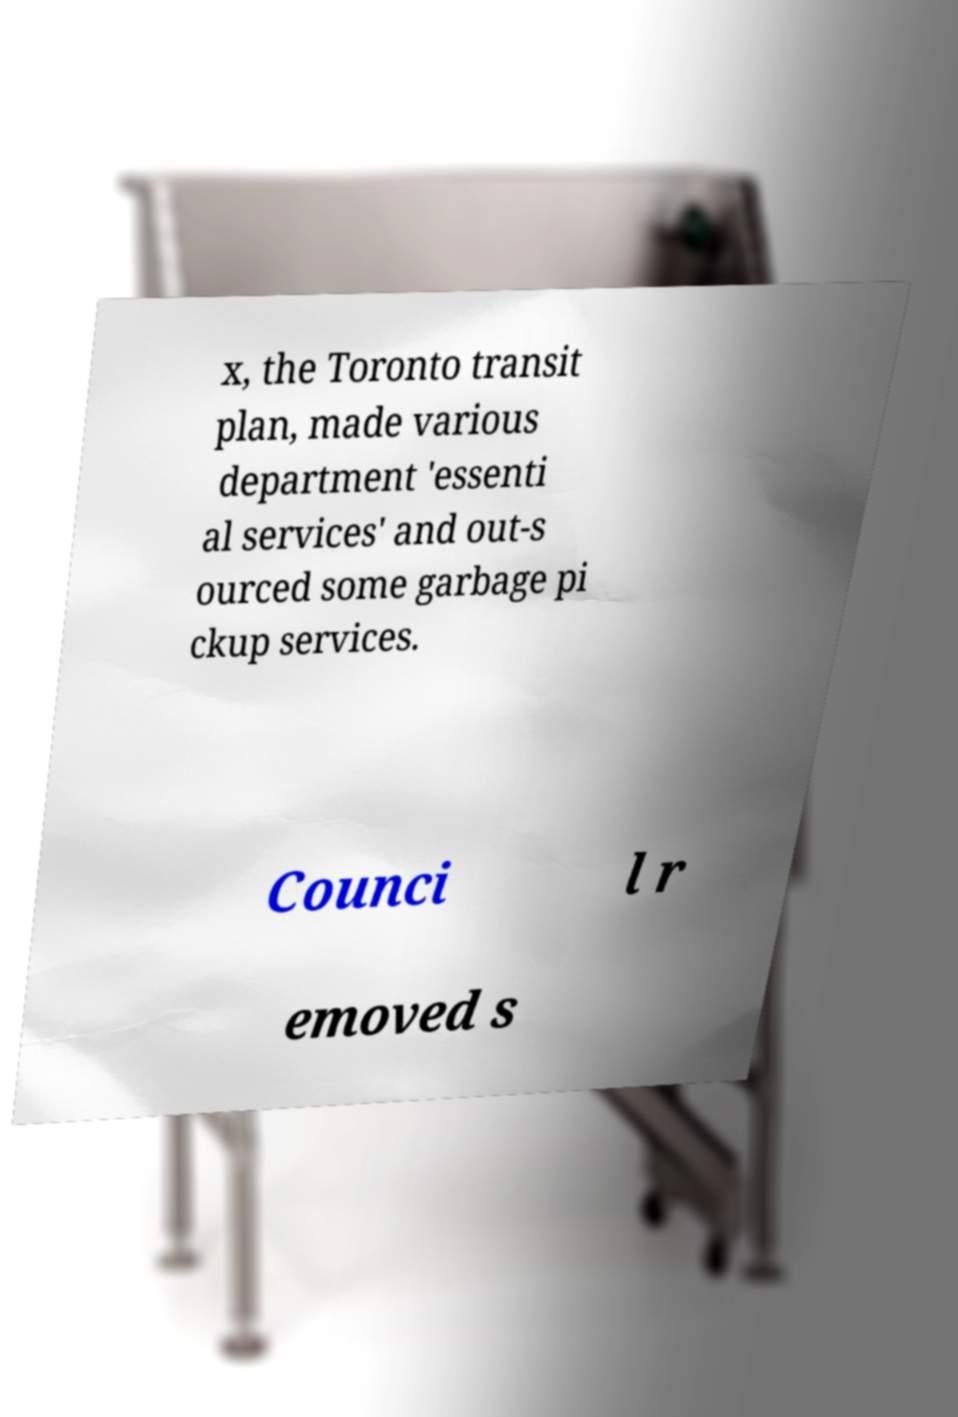Can you accurately transcribe the text from the provided image for me? x, the Toronto transit plan, made various department 'essenti al services' and out-s ourced some garbage pi ckup services. Counci l r emoved s 